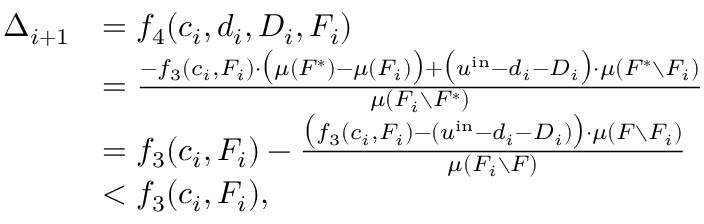<formula> <loc_0><loc_0><loc_500><loc_500>\begin{array} { r l } { \Delta _ { i + 1 } } & { = f _ { 4 } ( c _ { i } , d _ { i } , D _ { i } , F _ { i } ) } & { = \frac { - f _ { 3 } ( c _ { i } , F _ { i } ) \cdot \left ( \mu ( F ^ { * } ) - \mu ( F _ { i } ) \right ) + \left ( u ^ { i n } - d _ { i } - D _ { i } \right ) \cdot \mu ( F ^ { * } \ F _ { i } ) } { \mu ( F _ { i } \ F ^ { * } ) } } & { = f _ { 3 } ( c _ { i } , F _ { i } ) - \frac { \left ( f _ { 3 } ( c _ { i } , F _ { i } ) - ( u ^ { i n } - d _ { i } - D _ { i } ) \right ) \cdot \mu ( F \ F _ { i } ) } { \mu ( F _ { i } \ F ) } } & { < f _ { 3 } ( c _ { i } , F _ { i } ) , } \end{array}</formula> 